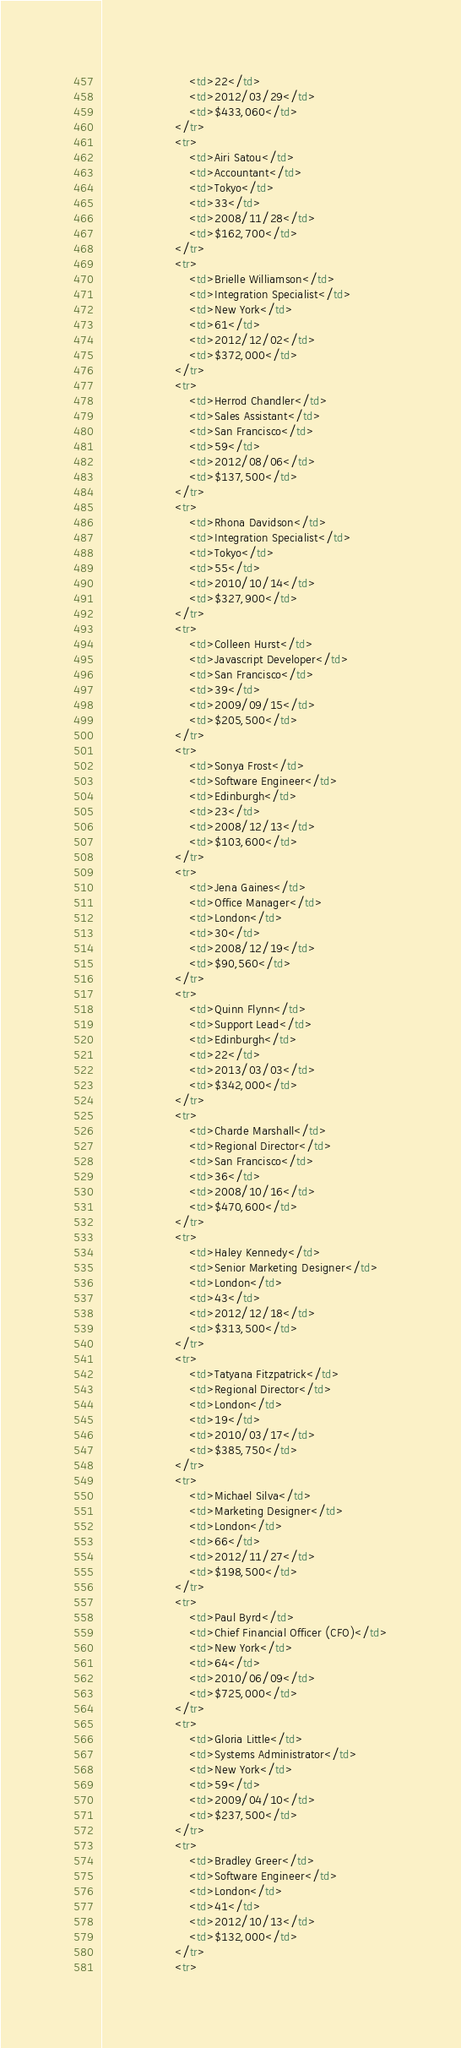<code> <loc_0><loc_0><loc_500><loc_500><_HTML_>						<td>22</td>
						<td>2012/03/29</td>
						<td>$433,060</td>
					</tr>
					<tr>
						<td>Airi Satou</td>
						<td>Accountant</td>
						<td>Tokyo</td>
						<td>33</td>
						<td>2008/11/28</td>
						<td>$162,700</td>
					</tr>
					<tr>
						<td>Brielle Williamson</td>
						<td>Integration Specialist</td>
						<td>New York</td>
						<td>61</td>
						<td>2012/12/02</td>
						<td>$372,000</td>
					</tr>
					<tr>
						<td>Herrod Chandler</td>
						<td>Sales Assistant</td>
						<td>San Francisco</td>
						<td>59</td>
						<td>2012/08/06</td>
						<td>$137,500</td>
					</tr>
					<tr>
						<td>Rhona Davidson</td>
						<td>Integration Specialist</td>
						<td>Tokyo</td>
						<td>55</td>
						<td>2010/10/14</td>
						<td>$327,900</td>
					</tr>
					<tr>
						<td>Colleen Hurst</td>
						<td>Javascript Developer</td>
						<td>San Francisco</td>
						<td>39</td>
						<td>2009/09/15</td>
						<td>$205,500</td>
					</tr>
					<tr>
						<td>Sonya Frost</td>
						<td>Software Engineer</td>
						<td>Edinburgh</td>
						<td>23</td>
						<td>2008/12/13</td>
						<td>$103,600</td>
					</tr>
					<tr>
						<td>Jena Gaines</td>
						<td>Office Manager</td>
						<td>London</td>
						<td>30</td>
						<td>2008/12/19</td>
						<td>$90,560</td>
					</tr>
					<tr>
						<td>Quinn Flynn</td>
						<td>Support Lead</td>
						<td>Edinburgh</td>
						<td>22</td>
						<td>2013/03/03</td>
						<td>$342,000</td>
					</tr>
					<tr>
						<td>Charde Marshall</td>
						<td>Regional Director</td>
						<td>San Francisco</td>
						<td>36</td>
						<td>2008/10/16</td>
						<td>$470,600</td>
					</tr>
					<tr>
						<td>Haley Kennedy</td>
						<td>Senior Marketing Designer</td>
						<td>London</td>
						<td>43</td>
						<td>2012/12/18</td>
						<td>$313,500</td>
					</tr>
					<tr>
						<td>Tatyana Fitzpatrick</td>
						<td>Regional Director</td>
						<td>London</td>
						<td>19</td>
						<td>2010/03/17</td>
						<td>$385,750</td>
					</tr>
					<tr>
						<td>Michael Silva</td>
						<td>Marketing Designer</td>
						<td>London</td>
						<td>66</td>
						<td>2012/11/27</td>
						<td>$198,500</td>
					</tr>
					<tr>
						<td>Paul Byrd</td>
						<td>Chief Financial Officer (CFO)</td>
						<td>New York</td>
						<td>64</td>
						<td>2010/06/09</td>
						<td>$725,000</td>
					</tr>
					<tr>
						<td>Gloria Little</td>
						<td>Systems Administrator</td>
						<td>New York</td>
						<td>59</td>
						<td>2009/04/10</td>
						<td>$237,500</td>
					</tr>
					<tr>
						<td>Bradley Greer</td>
						<td>Software Engineer</td>
						<td>London</td>
						<td>41</td>
						<td>2012/10/13</td>
						<td>$132,000</td>
					</tr>
					<tr></code> 